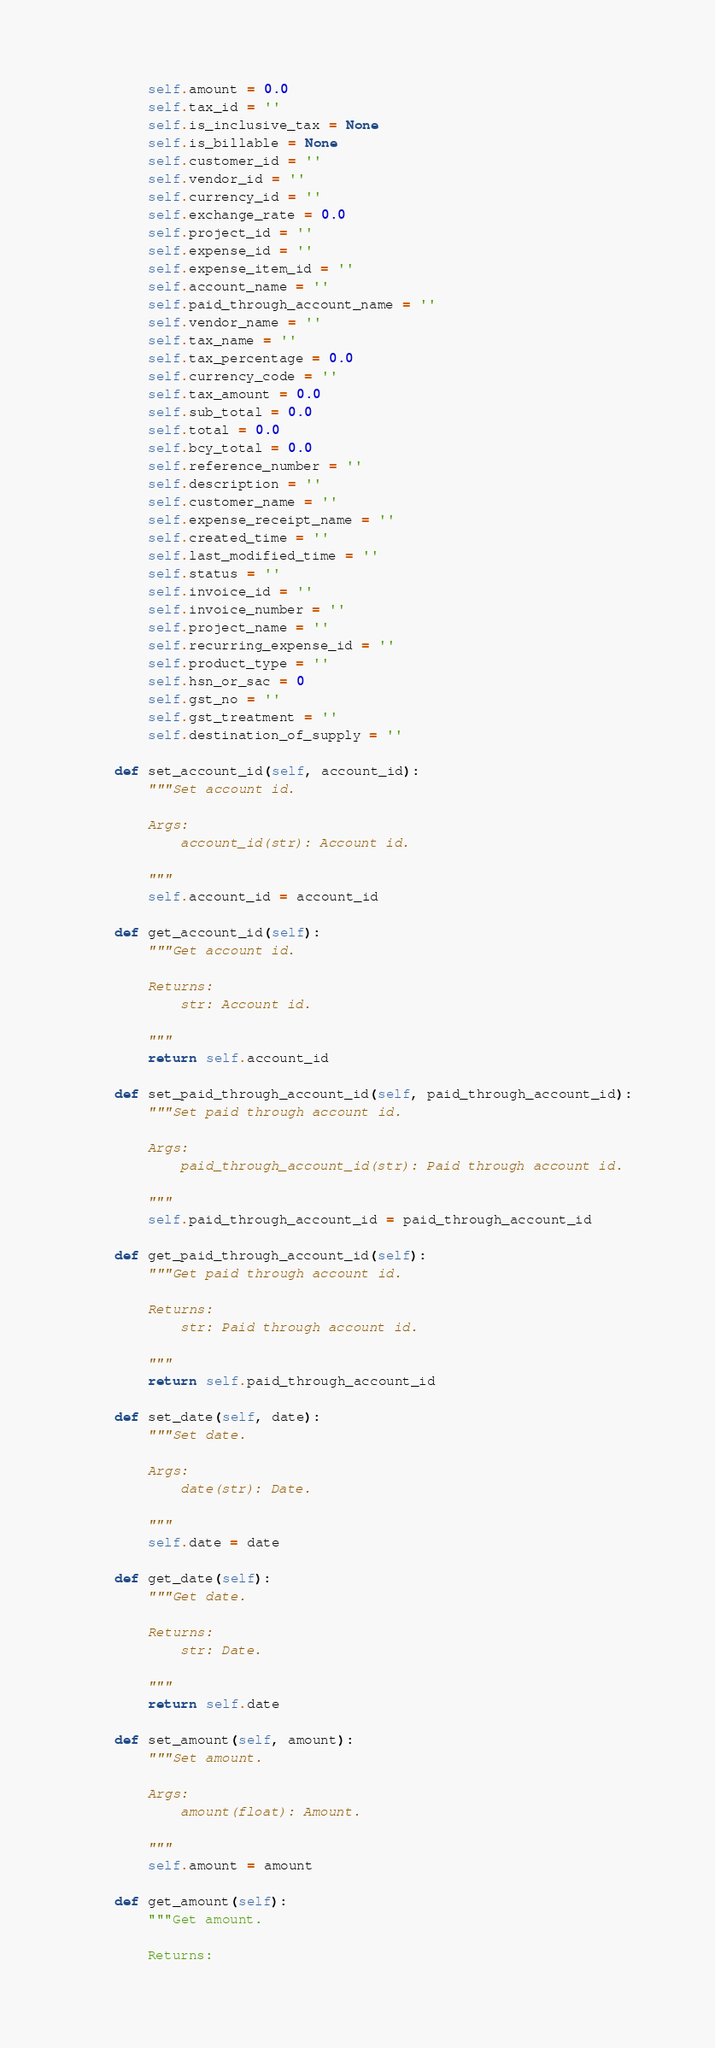<code> <loc_0><loc_0><loc_500><loc_500><_Python_>        self.amount = 0.0
        self.tax_id = ''
        self.is_inclusive_tax = None
        self.is_billable = None
        self.customer_id = ''
        self.vendor_id = ''
        self.currency_id = ''
        self.exchange_rate = 0.0
        self.project_id = ''
        self.expense_id = ''
        self.expense_item_id = ''
        self.account_name = ''
        self.paid_through_account_name = ''
        self.vendor_name = ''
        self.tax_name = ''
        self.tax_percentage = 0.0
        self.currency_code = ''
        self.tax_amount = 0.0
        self.sub_total = 0.0
        self.total = 0.0
        self.bcy_total = 0.0
        self.reference_number = ''
        self.description = ''
        self.customer_name = ''
        self.expense_receipt_name = ''
        self.created_time = ''
        self.last_modified_time = '' 
        self.status = ''
        self.invoice_id = ''
        self.invoice_number = ''
        self.project_name = ''
        self.recurring_expense_id = ''
        self.product_type = ''
        self.hsn_or_sac = 0
        self.gst_no = ''
        self.gst_treatment = ''
        self.destination_of_supply = ''

    def set_account_id(self, account_id):
        """Set account id.

        Args:
            account_id(str): Account id.

        """
        self.account_id = account_id

    def get_account_id(self): 
        """Get account id.

        Returns:
            str: Account id.

        """
        return self.account_id
  
    def set_paid_through_account_id(self, paid_through_account_id):
        """Set paid through account id.

        Args:
            paid_through_account_id(str): Paid through account id.

        """
        self.paid_through_account_id = paid_through_account_id

    def get_paid_through_account_id(self):
        """Get paid through account id.
 
        Returns:
            str: Paid through account id.

        """
        return self.paid_through_account_id
   
    def set_date(self, date):
        """Set date.

        Args:
            date(str): Date.

        """
        self.date = date

    def get_date(self):
        """Get date.

        Returns:
            str: Date.

        """
        return self.date
  
    def set_amount(self, amount):
        """Set amount.

        Args: 
            amount(float): Amount.

        """
        self.amount = amount

    def get_amount(self):
        """Get amount.

        Returns:</code> 